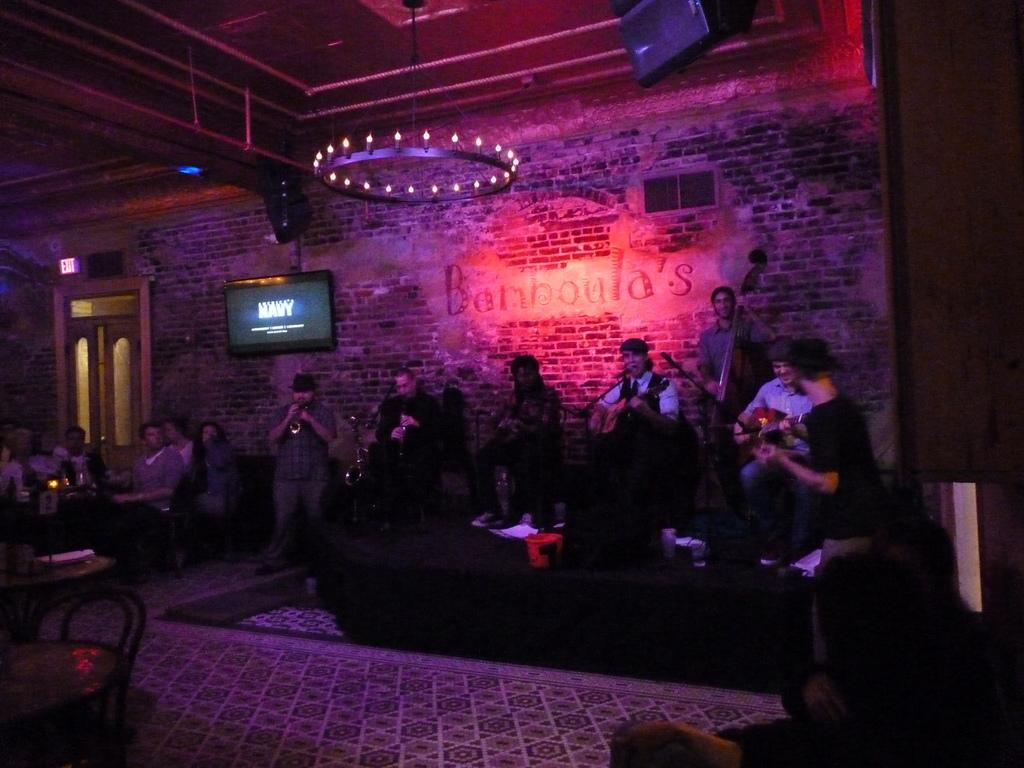What type of structure can be seen in the image? There is a wall in the image. What objects are present that might provide light? There are candles in the image. What might be used for displaying information or entertainment? There is a screen in the image. Is there a way to enter or exit the space in the image? Yes, there is a door in the image. Who might be present in the image? There is a group of people in the image. What is present for people to sit or place items? There is a table in the image. What type of activity might be taking place in the image? There are musical instruments in the image, suggesting that music-related activities might be happening. How would you describe the lighting in the image? The image is a little dark. Who is the owner of the toys in the image? There are no toys present in the image. What idea is being discussed by the group of people in the image? The image does not provide any information about what the group of people might be discussing or thinking about. 